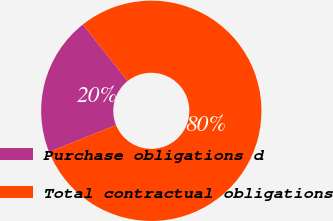<chart> <loc_0><loc_0><loc_500><loc_500><pie_chart><fcel>Purchase obligations d<fcel>Total contractual obligations<nl><fcel>20.43%<fcel>79.57%<nl></chart> 